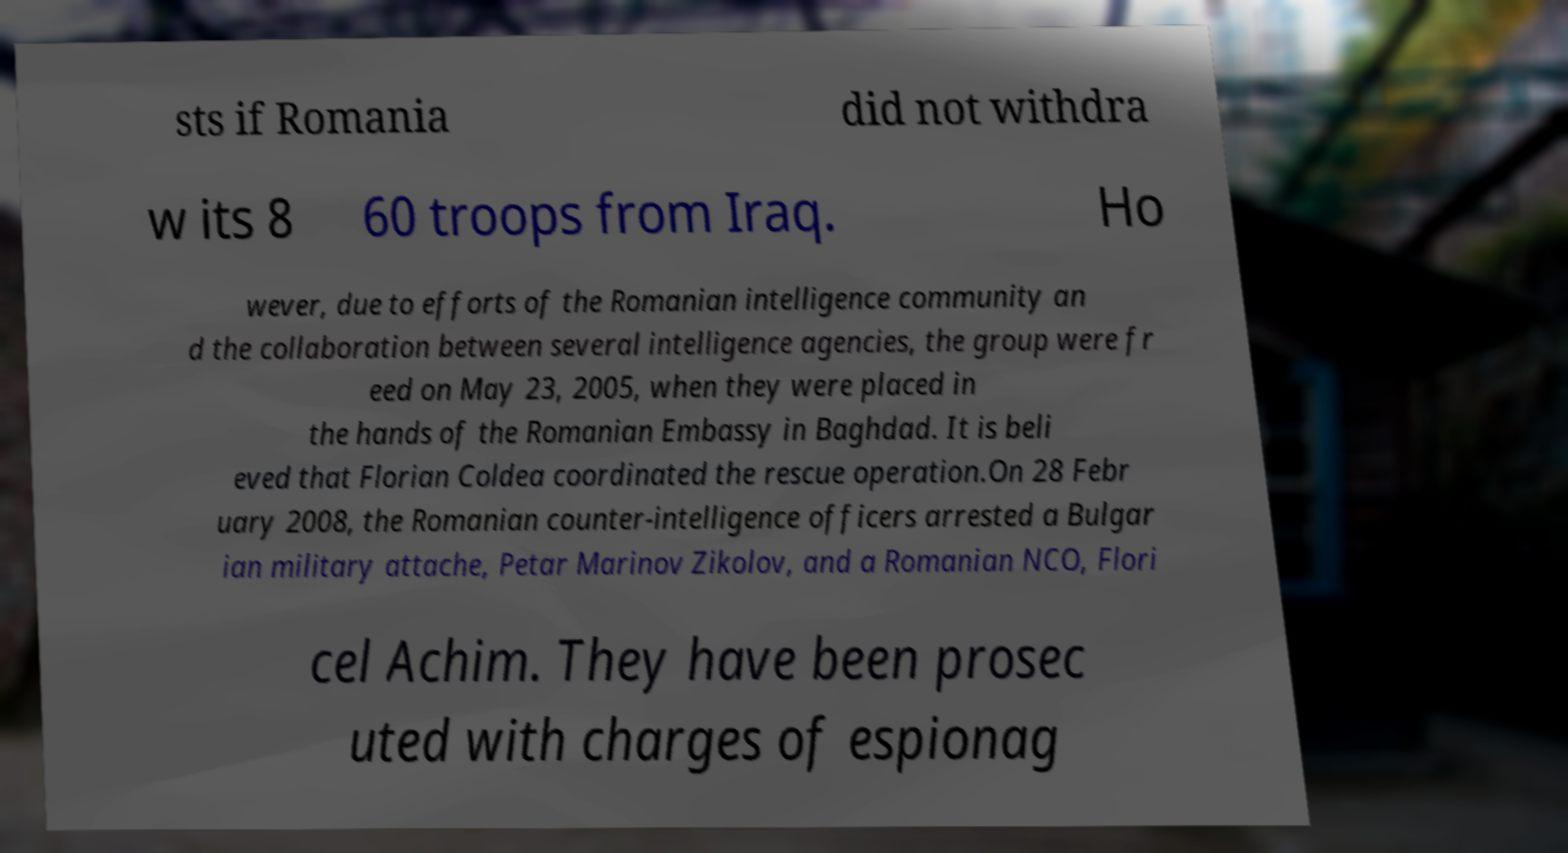Could you extract and type out the text from this image? sts if Romania did not withdra w its 8 60 troops from Iraq. Ho wever, due to efforts of the Romanian intelligence community an d the collaboration between several intelligence agencies, the group were fr eed on May 23, 2005, when they were placed in the hands of the Romanian Embassy in Baghdad. It is beli eved that Florian Coldea coordinated the rescue operation.On 28 Febr uary 2008, the Romanian counter-intelligence officers arrested a Bulgar ian military attache, Petar Marinov Zikolov, and a Romanian NCO, Flori cel Achim. They have been prosec uted with charges of espionag 